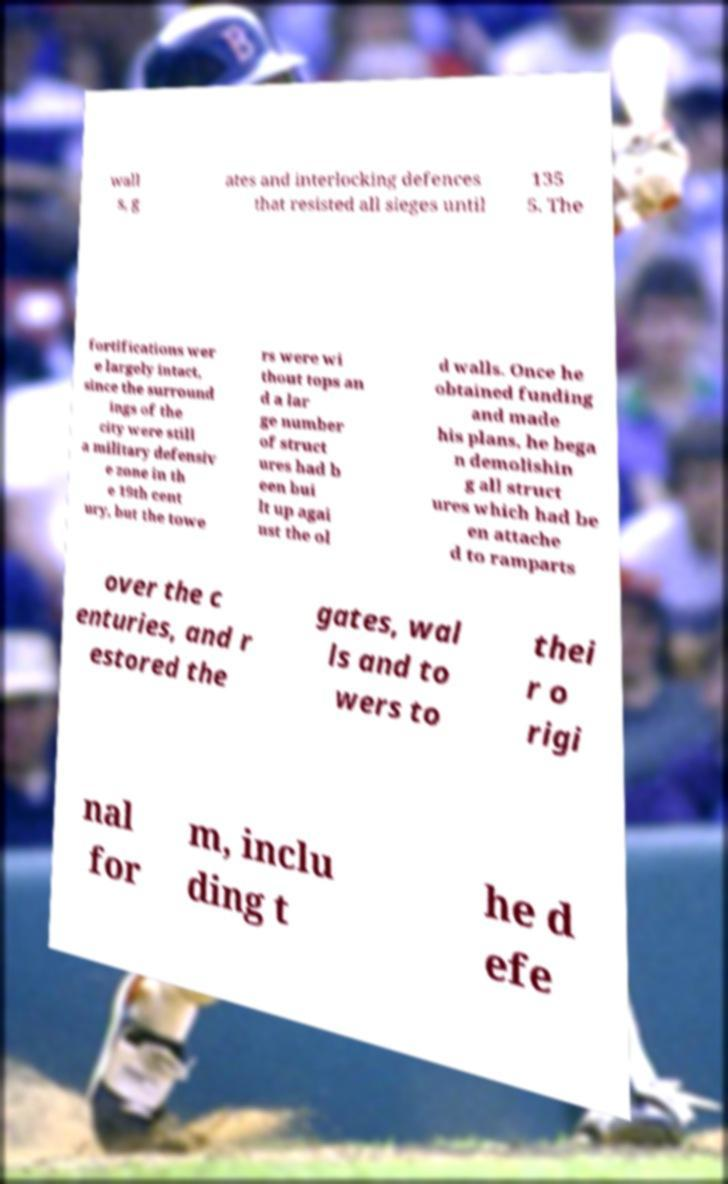Can you read and provide the text displayed in the image?This photo seems to have some interesting text. Can you extract and type it out for me? wall s, g ates and interlocking defences that resisted all sieges until 135 5. The fortifications wer e largely intact, since the surround ings of the city were still a military defensiv e zone in th e 19th cent ury, but the towe rs were wi thout tops an d a lar ge number of struct ures had b een bui lt up agai nst the ol d walls. Once he obtained funding and made his plans, he bega n demolishin g all struct ures which had be en attache d to ramparts over the c enturies, and r estored the gates, wal ls and to wers to thei r o rigi nal for m, inclu ding t he d efe 